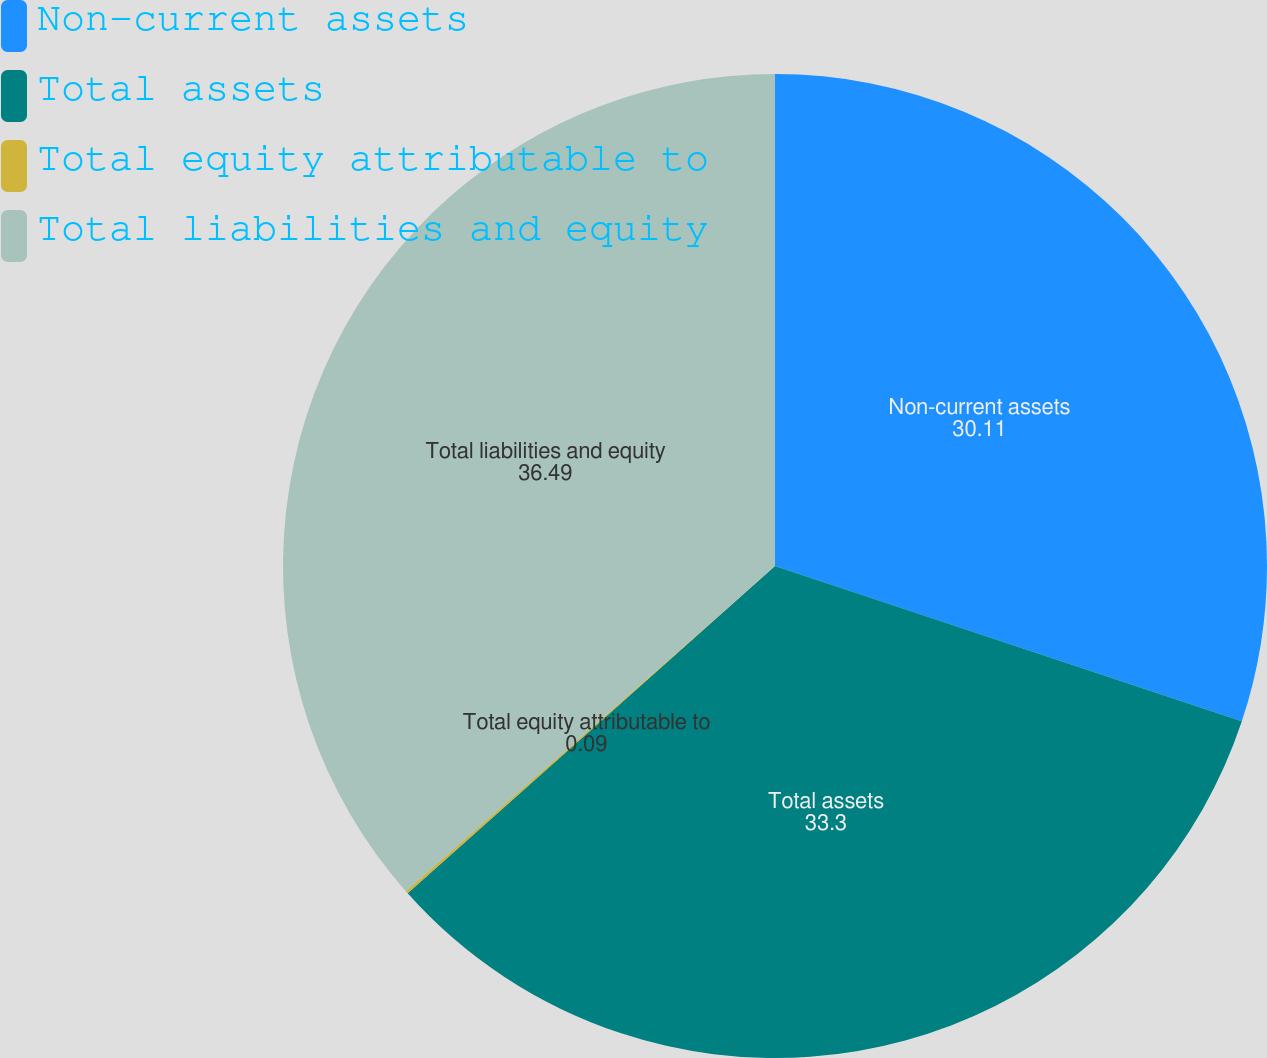Convert chart to OTSL. <chart><loc_0><loc_0><loc_500><loc_500><pie_chart><fcel>Non-current assets<fcel>Total assets<fcel>Total equity attributable to<fcel>Total liabilities and equity<nl><fcel>30.11%<fcel>33.3%<fcel>0.09%<fcel>36.49%<nl></chart> 